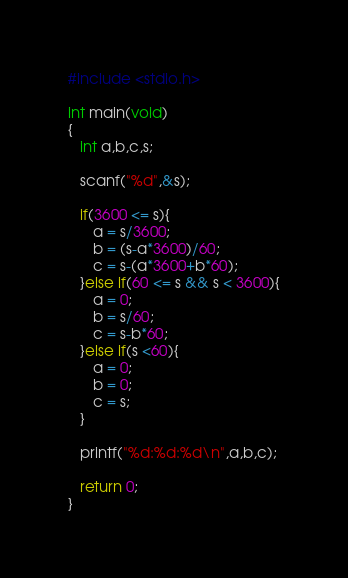<code> <loc_0><loc_0><loc_500><loc_500><_C_>#include <stdio.h>

int main(void)
{
   int a,b,c,s;

   scanf("%d",&s);

   if(3600 <= s){
      a = s/3600;
      b = (s-a*3600)/60;
      c = s-(a*3600+b*60);
   }else if(60 <= s && s < 3600){
      a = 0;
      b = s/60;
      c = s-b*60;
   }else if(s <60){
      a = 0;
      b = 0;
      c = s;
   }

   printf("%d:%d:%d\n",a,b,c);

   return 0;
}</code> 